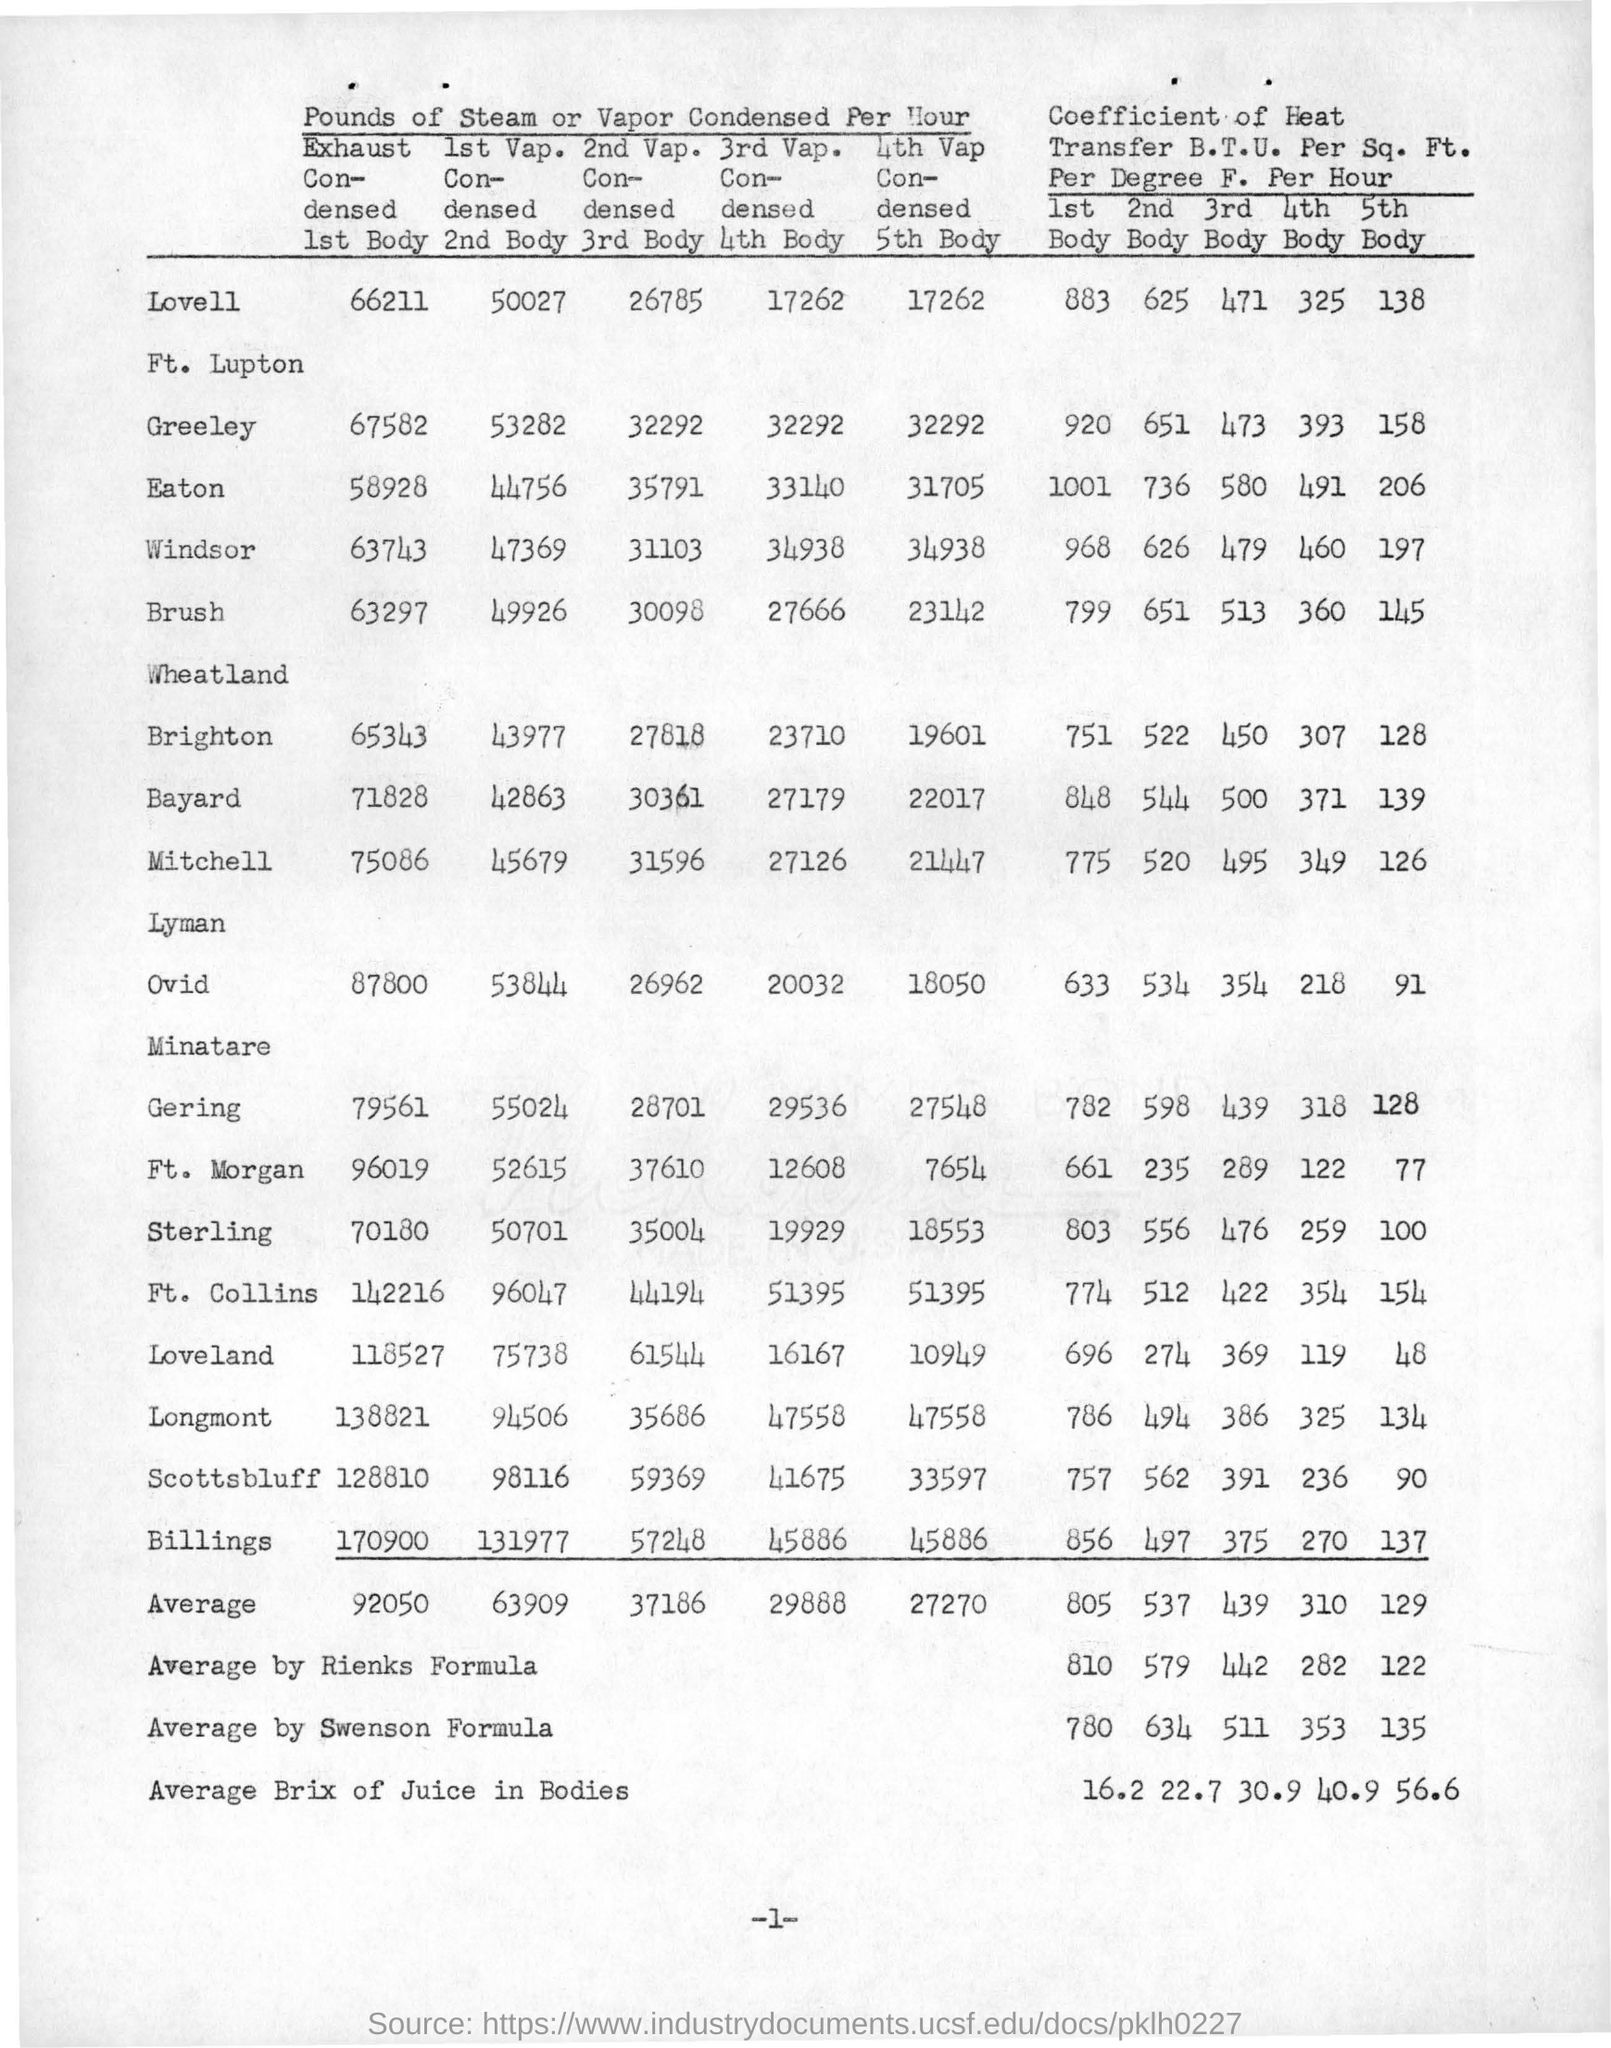what is the value of average by swenson formula for the coefficient of heat in 5th body ?
 135 